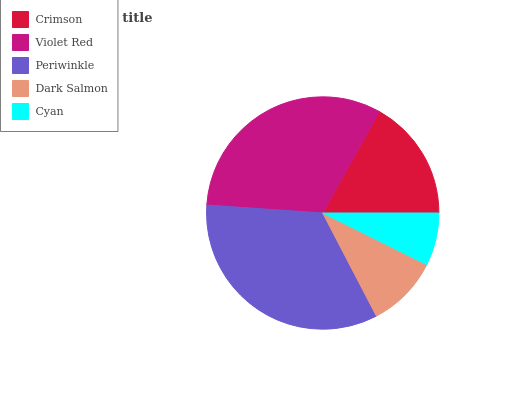Is Cyan the minimum?
Answer yes or no. Yes. Is Periwinkle the maximum?
Answer yes or no. Yes. Is Violet Red the minimum?
Answer yes or no. No. Is Violet Red the maximum?
Answer yes or no. No. Is Violet Red greater than Crimson?
Answer yes or no. Yes. Is Crimson less than Violet Red?
Answer yes or no. Yes. Is Crimson greater than Violet Red?
Answer yes or no. No. Is Violet Red less than Crimson?
Answer yes or no. No. Is Crimson the high median?
Answer yes or no. Yes. Is Crimson the low median?
Answer yes or no. Yes. Is Periwinkle the high median?
Answer yes or no. No. Is Cyan the low median?
Answer yes or no. No. 